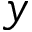Convert formula to latex. <formula><loc_0><loc_0><loc_500><loc_500>y</formula> 